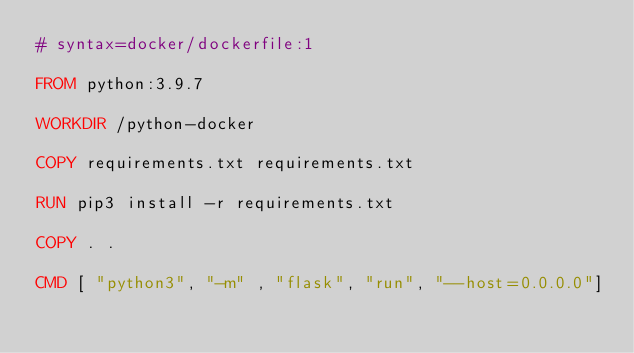Convert code to text. <code><loc_0><loc_0><loc_500><loc_500><_Dockerfile_># syntax=docker/dockerfile:1

FROM python:3.9.7

WORKDIR /python-docker

COPY requirements.txt requirements.txt

RUN pip3 install -r requirements.txt

COPY . .

CMD [ "python3", "-m" , "flask", "run", "--host=0.0.0.0"]</code> 